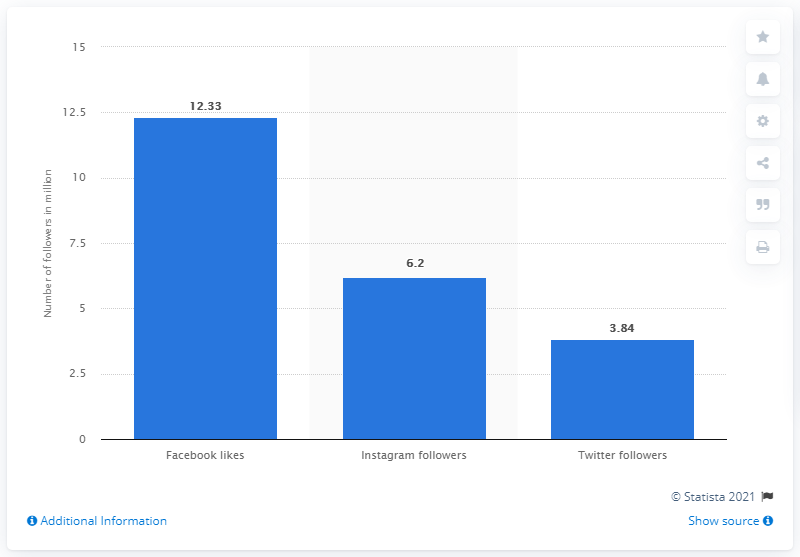Draw attention to some important aspects in this diagram. In November 2019, Tottenham Hotspur had 12,330 Facebook fans. 